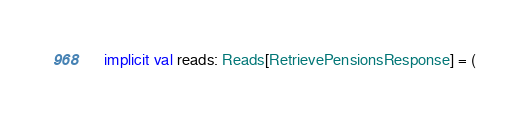Convert code to text. <code><loc_0><loc_0><loc_500><loc_500><_Scala_>
  implicit val reads: Reads[RetrievePensionsResponse] = (</code> 